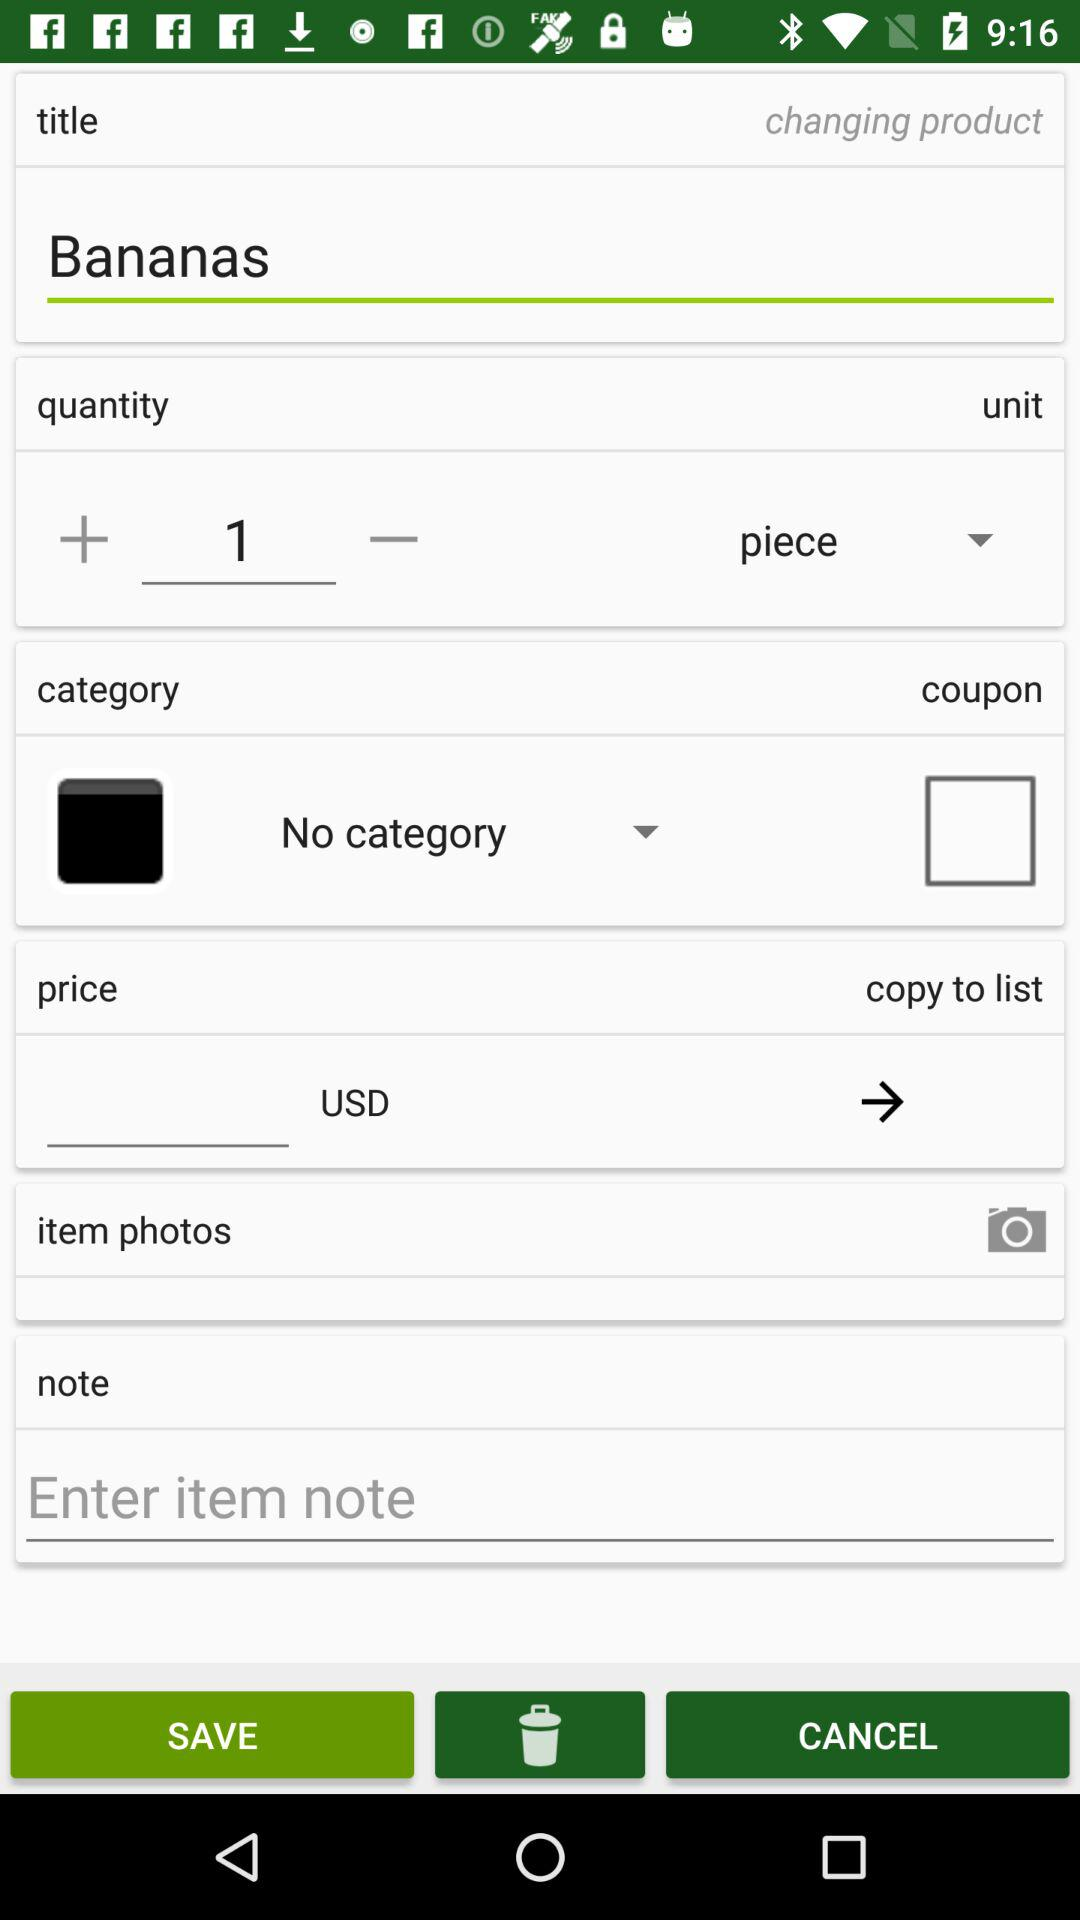What is the item name? The item name is "Bananas". 